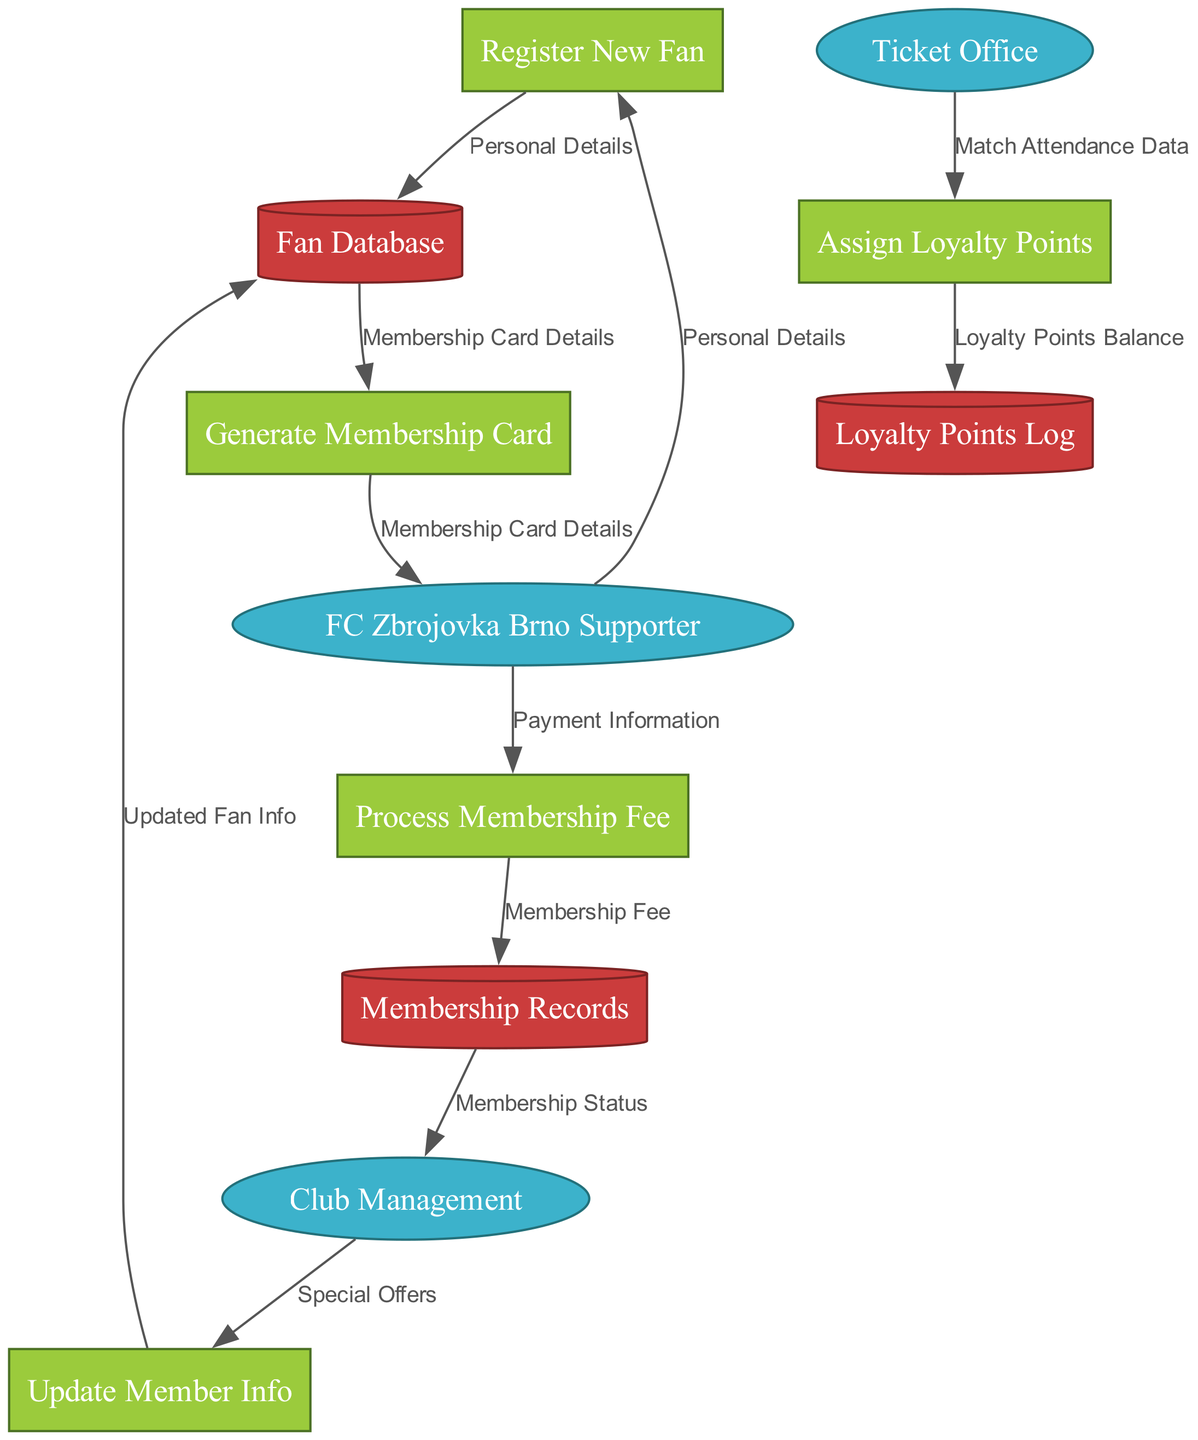What are the external entities in this diagram? The external entities are defined in the diagram, which are specifically labeled as such. I can list them as "FC Zbrojovka Brno Supporter," "Club Management," and "Ticket Office."
Answer: FC Zbrojovka Brno Supporter, Club Management, Ticket Office How many processes are listed in the diagram? The processes are visually identifiable in the diagram under the labeled section. There are five processes: "Register New Fan," "Update Member Info," "Process Membership Fee," "Generate Membership Card," and "Assign Loyalty Points."
Answer: 5 Which process generates the membership card? The diagram shows clear flow lines from the node "Generate Membership Card." By following the data flow, I can see it outputs "Membership Card Details," confirming that this process is responsible for generating the membership card.
Answer: Generate Membership Card What data flows from "FC Zbrojovka Brno Supporter" to "Process Membership Fee"? Following the edge labeled with the data flow, it is stated that the flow is "Payment Information" flowing from "FC Zbrojovka Brno Supporter" to "Process Membership Fee.” Hence, this is the specific data flow.
Answer: Payment Information How does "Club Management" receive membership status? The flow indicates that "Membership Records" directly sends the "Membership Status" to "Club Management." I can trace this through the connected edges in the diagram.
Answer: Membership Records What data store is updated when a member's information is updated? The flow from "Update Member Info" to "Fan Database" shows which data store is affected. This connection reveals that the updating process directly modifies the fan details stored there.
Answer: Fan Database How many data flows are present in the diagram? By counting the edges labeled with data flows, I find there are a total of eight distinct flows that connect various processes and entities within the diagram.
Answer: 8 Which process is responsible for assigning loyalty points? The diagram specifically shows "Assign Loyalty Points" as a distinct process, supported by incoming data from "Ticket Office" related to "Match Attendance Data." Thus, this identifies the responsibility clearly.
Answer: Assign Loyalty Points 